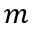Convert formula to latex. <formula><loc_0><loc_0><loc_500><loc_500>m</formula> 